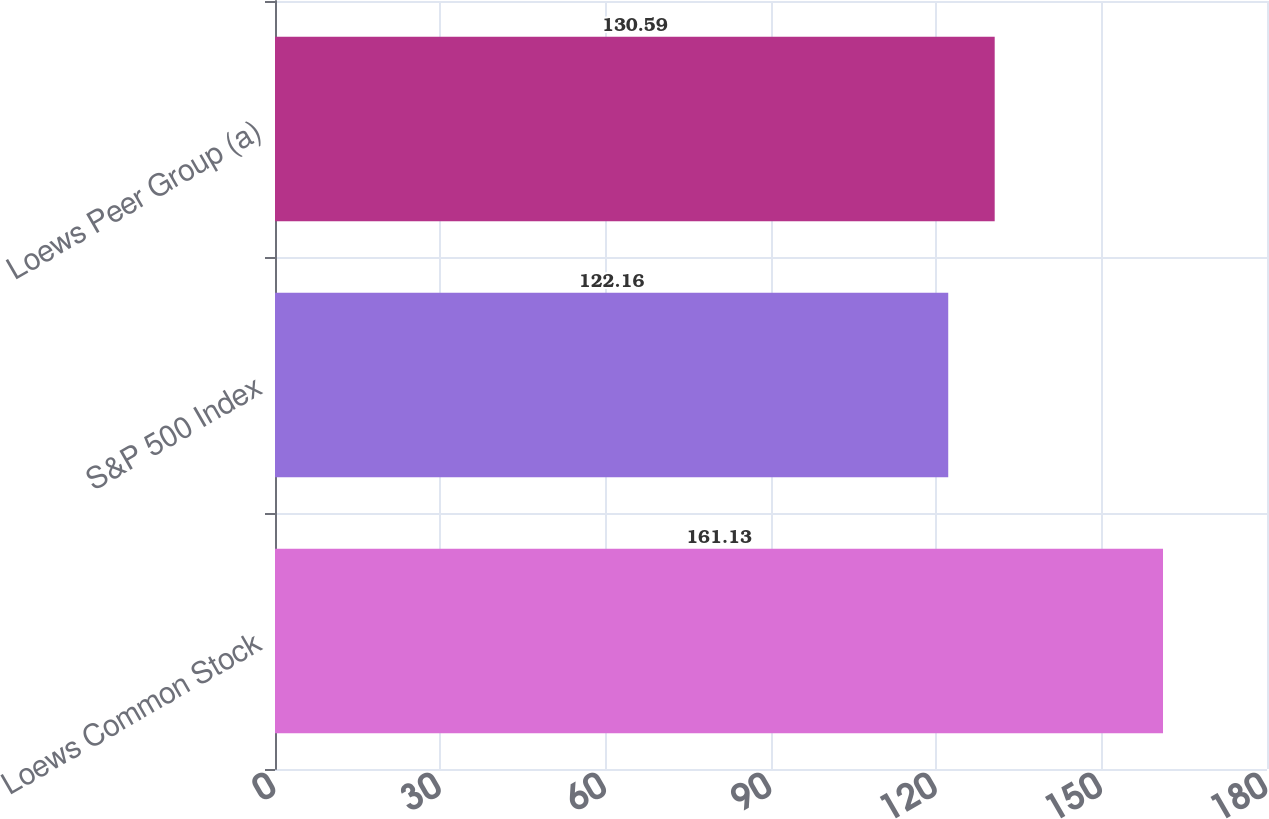Convert chart to OTSL. <chart><loc_0><loc_0><loc_500><loc_500><bar_chart><fcel>Loews Common Stock<fcel>S&P 500 Index<fcel>Loews Peer Group (a)<nl><fcel>161.13<fcel>122.16<fcel>130.59<nl></chart> 